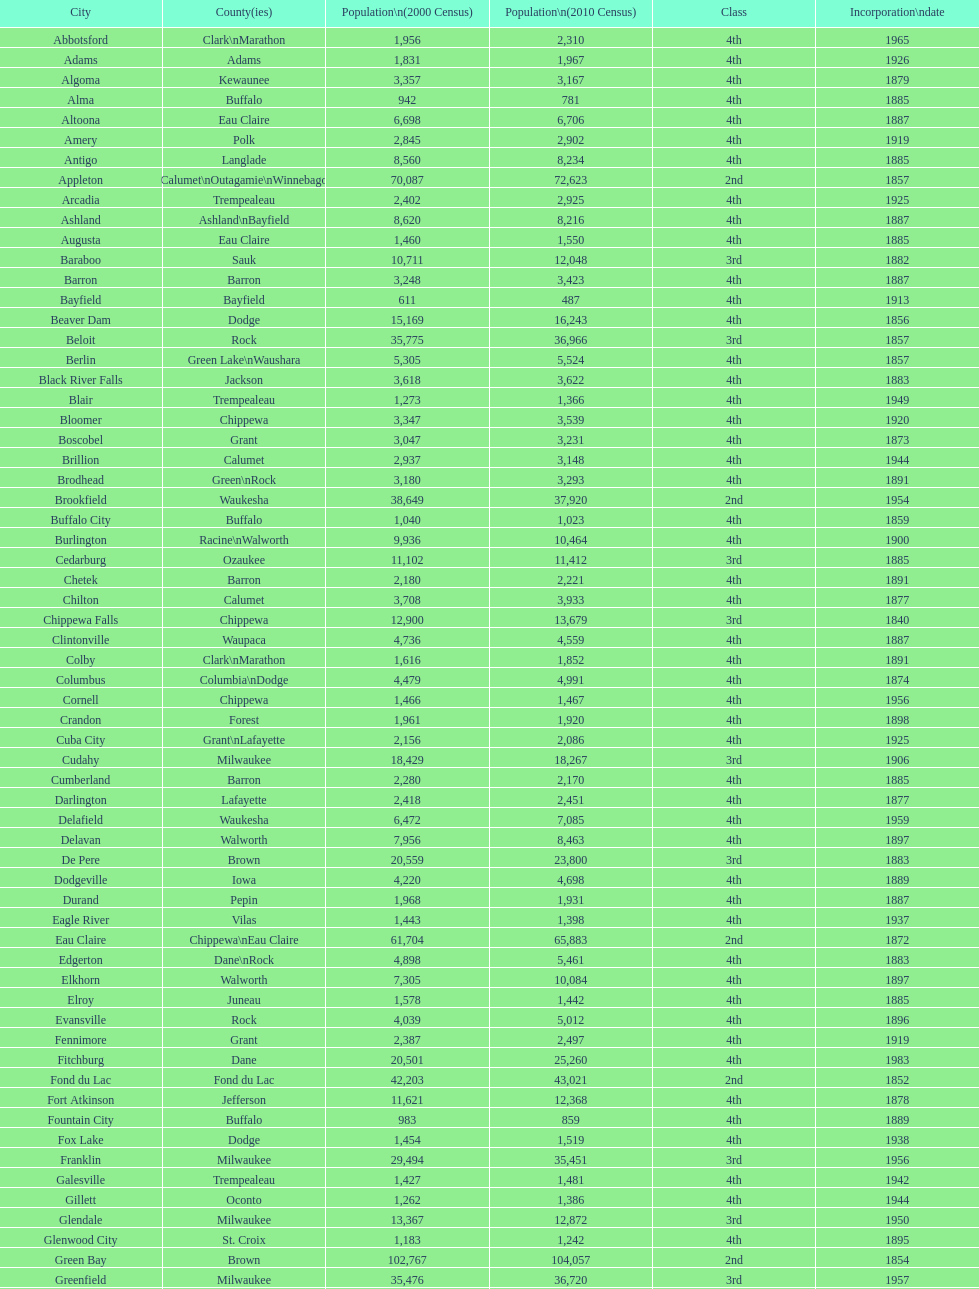Can you tell me the count of cities within wisconsin? 190. 